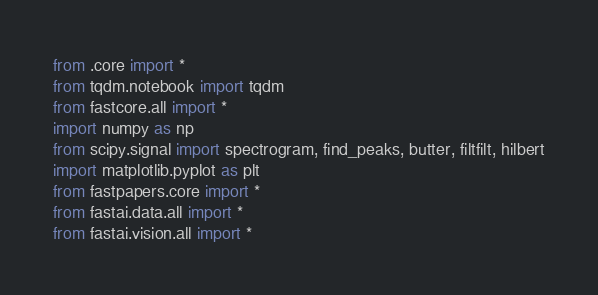Convert code to text. <code><loc_0><loc_0><loc_500><loc_500><_Python_>from .core import *
from tqdm.notebook import tqdm
from fastcore.all import *
import numpy as np
from scipy.signal import spectrogram, find_peaks, butter, filtfilt, hilbert
import matplotlib.pyplot as plt
from fastpapers.core import *
from fastai.data.all import *
from fastai.vision.all import *</code> 